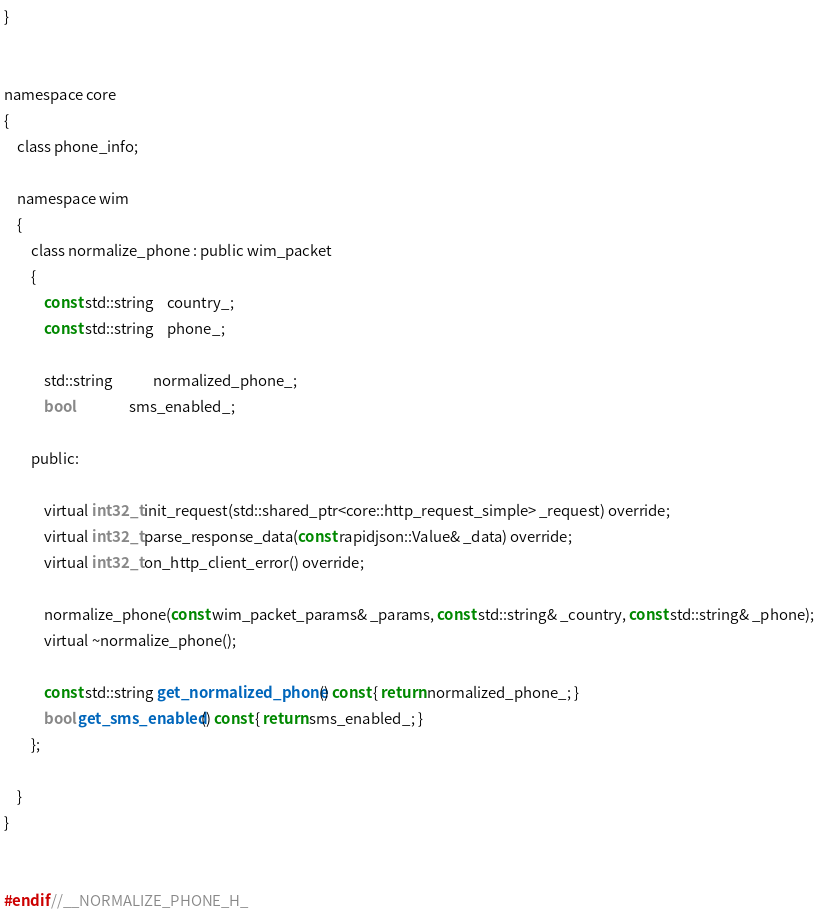<code> <loc_0><loc_0><loc_500><loc_500><_C_>}


namespace core
{
    class phone_info;

    namespace wim
    {
        class normalize_phone : public wim_packet
        {
            const std::string	country_;
            const std::string	phone_;

            std::string			normalized_phone_;
            bool				sms_enabled_;

        public:

            virtual int32_t init_request(std::shared_ptr<core::http_request_simple> _request) override;
            virtual int32_t parse_response_data(const rapidjson::Value& _data) override;
            virtual int32_t on_http_client_error() override;

            normalize_phone(const wim_packet_params& _params, const std::string& _country, const std::string& _phone);
            virtual ~normalize_phone();

            const std::string get_normalized_phone() const { return normalized_phone_; }
            bool get_sms_enabled() const { return sms_enabled_; }
        };

    }
}


#endif //__NORMALIZE_PHONE_H_</code> 